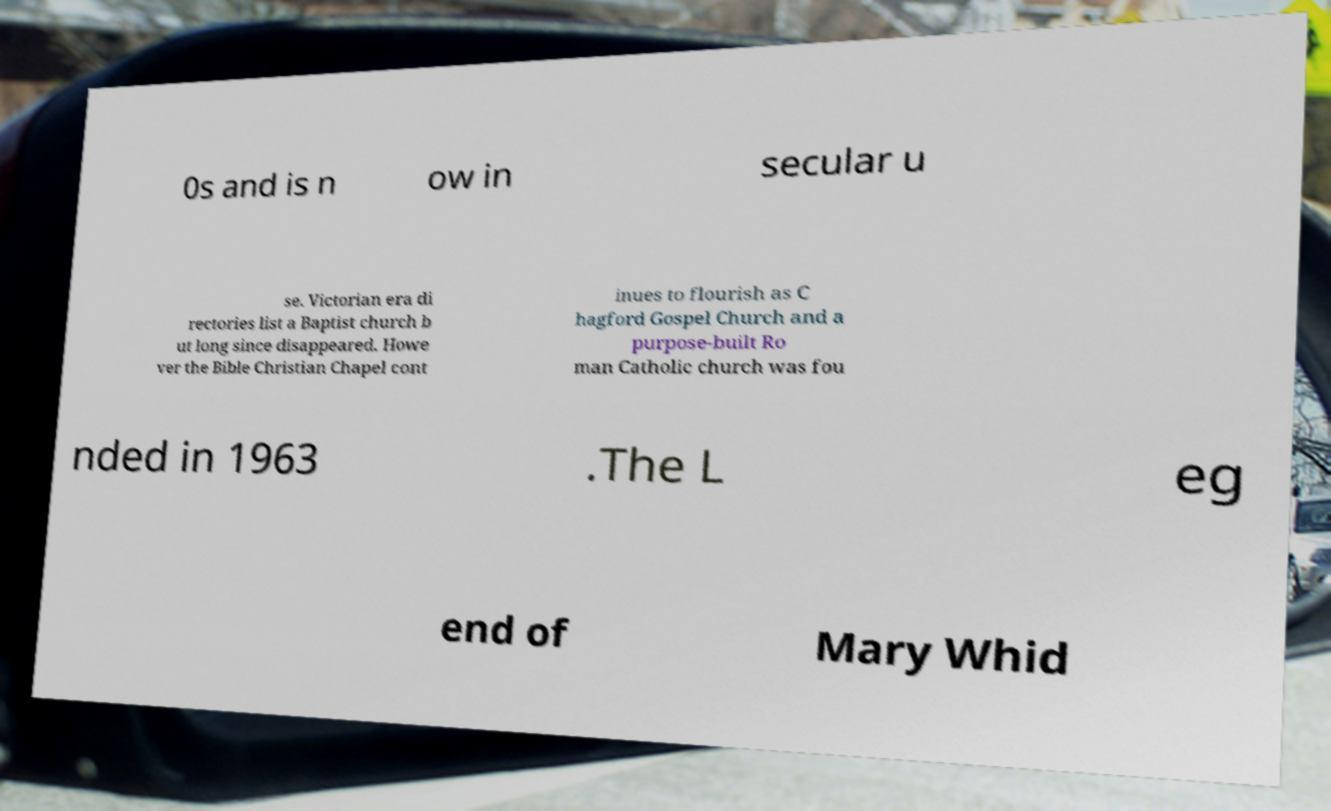Can you read and provide the text displayed in the image?This photo seems to have some interesting text. Can you extract and type it out for me? 0s and is n ow in secular u se. Victorian era di rectories list a Baptist church b ut long since disappeared. Howe ver the Bible Christian Chapel cont inues to flourish as C hagford Gospel Church and a purpose-built Ro man Catholic church was fou nded in 1963 .The L eg end of Mary Whid 